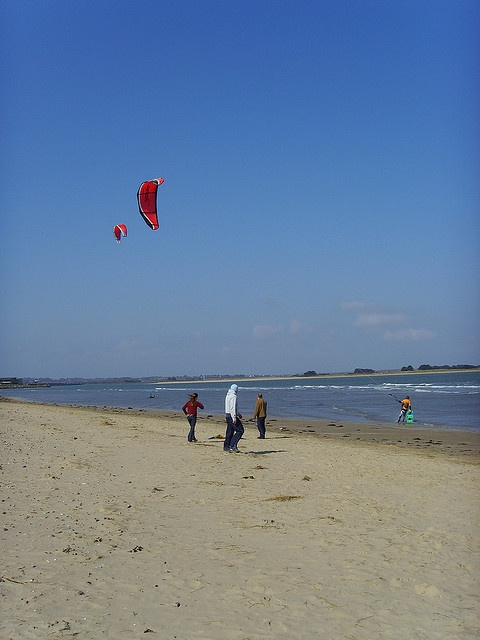Describe the objects in this image and their specific colors. I can see people in blue, black, lightgray, and gray tones, kite in blue, maroon, brown, and black tones, people in blue, black, maroon, and gray tones, people in blue, black, maroon, and gray tones, and people in blue, black, and gray tones in this image. 